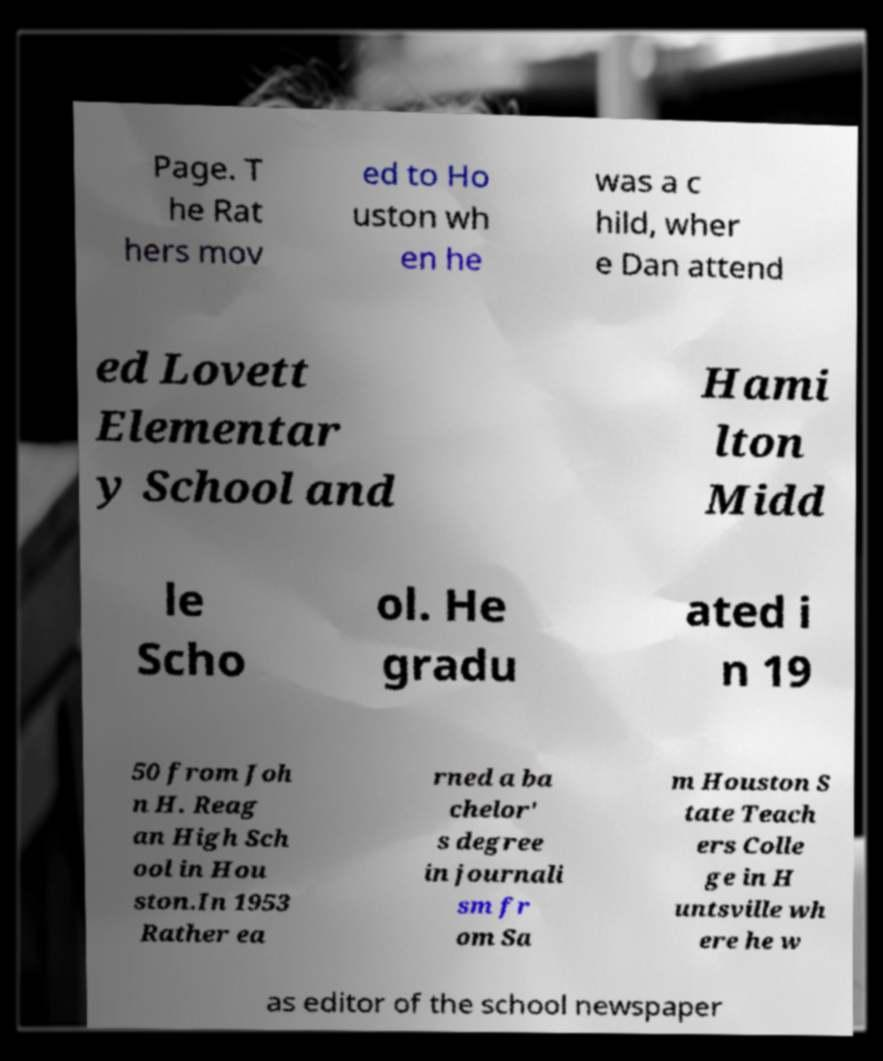Could you assist in decoding the text presented in this image and type it out clearly? Page. T he Rat hers mov ed to Ho uston wh en he was a c hild, wher e Dan attend ed Lovett Elementar y School and Hami lton Midd le Scho ol. He gradu ated i n 19 50 from Joh n H. Reag an High Sch ool in Hou ston.In 1953 Rather ea rned a ba chelor' s degree in journali sm fr om Sa m Houston S tate Teach ers Colle ge in H untsville wh ere he w as editor of the school newspaper 